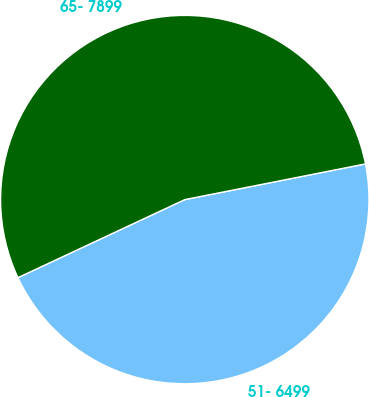Convert chart to OTSL. <chart><loc_0><loc_0><loc_500><loc_500><pie_chart><fcel>51- 6499<fcel>65- 7899<nl><fcel>46.14%<fcel>53.86%<nl></chart> 